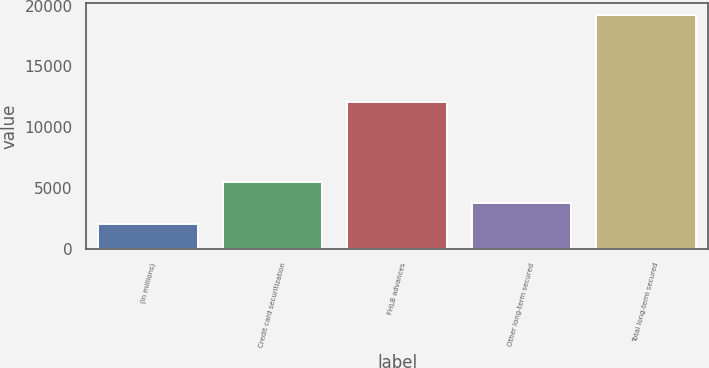Convert chart. <chart><loc_0><loc_0><loc_500><loc_500><bar_chart><fcel>(in millions)<fcel>Credit card securitization<fcel>FHLB advances<fcel>Other long-term secured<fcel>Total long-term secured<nl><fcel>2014<fcel>5458.8<fcel>12079<fcel>3736.4<fcel>19238<nl></chart> 